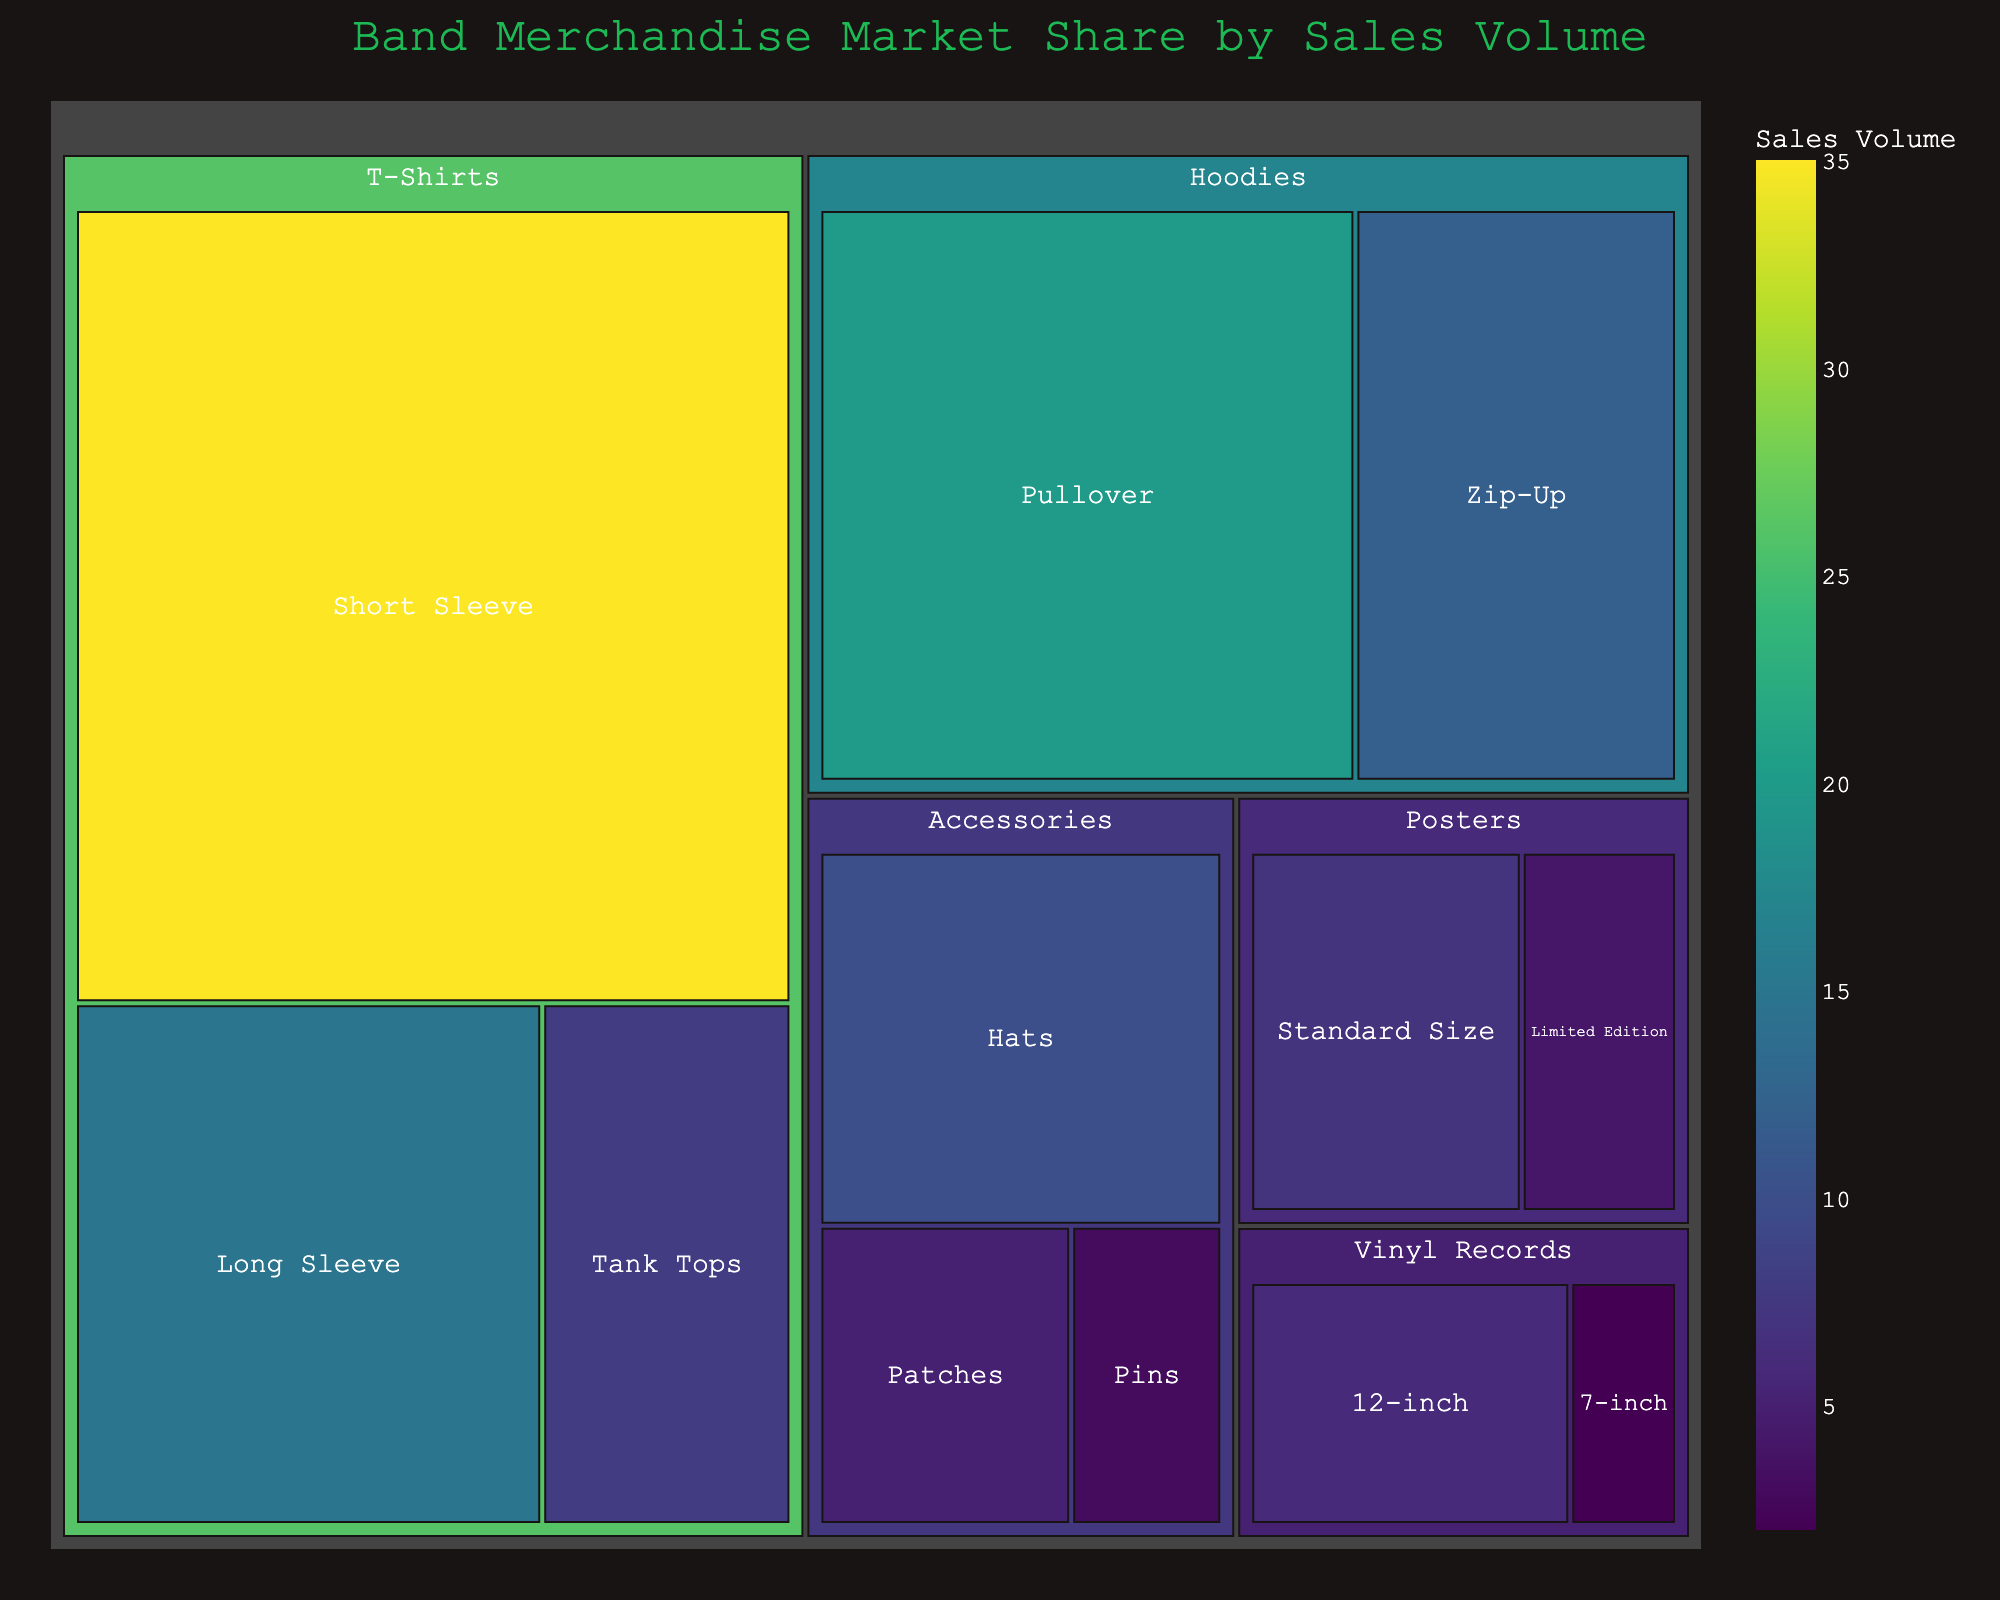What is the title of the Treemap? The title of the Treemap is typically displayed prominently at the top of the figure. It gives a clear indication of what the figure represents.
Answer: Band Merchandise Market Share by Sales Volume Which merchandise category has the highest sales volume? To determine the category with the highest sales volume, observe the largest area in the Treemap, as larger areas represent higher values.
Answer: T-Shirts How many subcategories are under the T-Shirts category? To find this, look closely at the sections within the T-Shirts category. Count each labeled subcategory.
Answer: 3 What is the total sales volume for all Hoodie subcategories combined? From the Treemap, identify the sales volumes for Pullover and Zip-Up subcategories under Hoodies. Sum them up: 20 (Pullover) + 12 (Zip-Up) = 32.
Answer: 32 Which subcategory in Accessories has the smallest sales volume? Within the Accessories category, compare the areas of the subcategories. The smallest area represents the smallest sales volume.
Answer: Pins Are there more sales of Posters or Vinyl Records? Sum the sales volume of all subcategories under Posters and Vinyl Records. For Posters: 7 (Standard Size) + 4 (Limited Edition) = 11. For Vinyl Records: 6 (12-inch) + 2 (7-inch) = 8. Compare the sums: 11 (Posters) > 8 (Vinyl Records).
Answer: Posters What is the combined sales volume of all items in the Treemap? Add the sales volumes of all subcategories across all categories: 35 + 15 + 8 + 20 + 12 + 10 + 5 + 3 + 7 + 4 + 6 + 2. This equals 127.
Answer: 127 Which category has the most subcategories? Count the number of subcategories within each category and identify the category with the highest count. For instance, T-Shirts (3), Hoodies (2), Accessories (3), Posters (2), Vinyl Records (2). Both T-Shirts and Accessories have 3 subcategories.
Answer: T-Shirts and Accessories Is the sales volume for Long Sleeve T-Shirts greater than that for Hats? Compare the values for Long Sleeve T-Shirts and Hats directly from the Treemap. Long Sleeve T-Shirts have a value of 15, while Hats have a value of 10.
Answer: Yes What's the average sales volume for subcategories under Posters? To find the average, sum the sales volumes of the subcategories within Posters and divide by the number of subcategories. (7 + 4) / 2 = 11 / 2 = 5.5.
Answer: 5.5 